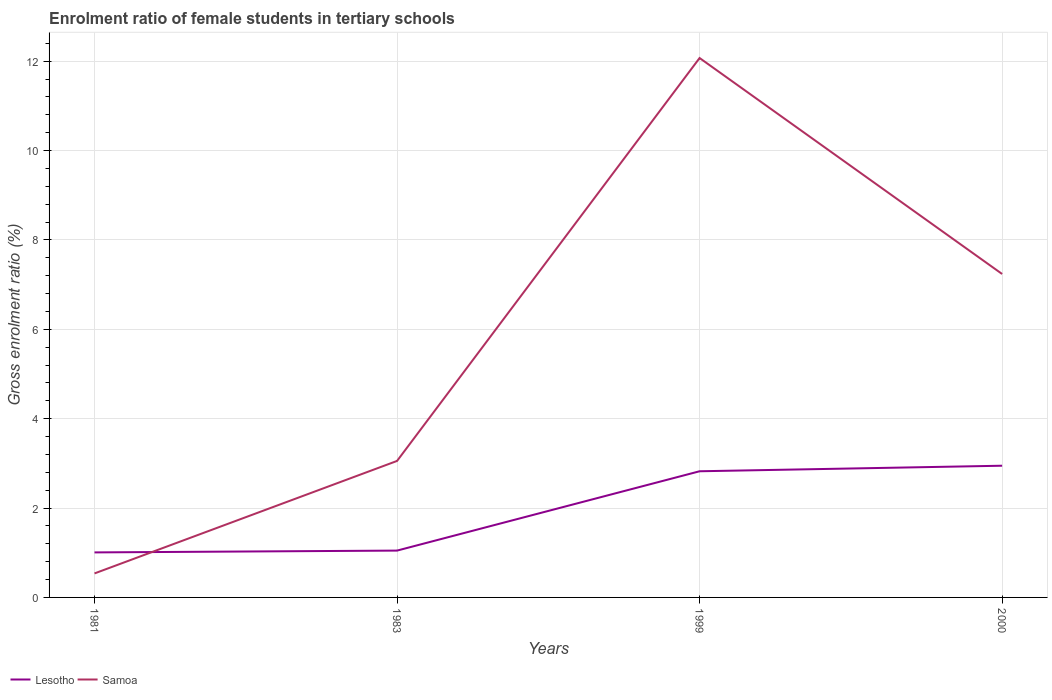How many different coloured lines are there?
Offer a terse response. 2. Across all years, what is the maximum enrolment ratio of female students in tertiary schools in Samoa?
Your response must be concise. 0.54. What is the total enrolment ratio of female students in tertiary schools in Lesotho in the graph?
Your response must be concise. -0.12. What is the difference between the highest and the second highest enrolment ratio of female students in tertiary schools in Samoa?
Make the answer very short. 11.53. What is the difference between the highest and the lowest enrolment ratio of female students in tertiary schools in Samoa?
Make the answer very short. 2. Is the enrolment ratio of female students in tertiary schools in Samoa strictly greater than the enrolment ratio of female students in tertiary schools in Lesotho over the years?
Keep it short and to the point. No. How many years are there in the graph?
Your response must be concise. 4. Does the graph contain any zero values?
Give a very brief answer. No. Where does the legend appear in the graph?
Your response must be concise. Bottom left. How many legend labels are there?
Make the answer very short. 2. What is the title of the graph?
Your response must be concise. Enrolment ratio of female students in tertiary schools. What is the label or title of the X-axis?
Give a very brief answer. Years. What is the label or title of the Y-axis?
Your answer should be very brief. Gross enrolment ratio (%). What is the Gross enrolment ratio (%) in Lesotho in 1981?
Offer a very short reply. 1.01. What is the Gross enrolment ratio (%) in Samoa in 1981?
Your answer should be compact. 0.54. What is the Gross enrolment ratio (%) in Lesotho in 1983?
Provide a succinct answer. 1.05. What is the Gross enrolment ratio (%) in Samoa in 1983?
Offer a terse response. 3.05. What is the Gross enrolment ratio (%) of Lesotho in 1999?
Offer a very short reply. 2.82. What is the Gross enrolment ratio (%) of Samoa in 1999?
Your response must be concise. 12.07. What is the Gross enrolment ratio (%) in Lesotho in 2000?
Your response must be concise. 2.95. What is the Gross enrolment ratio (%) of Samoa in 2000?
Offer a very short reply. 7.24. Across all years, what is the maximum Gross enrolment ratio (%) of Lesotho?
Offer a very short reply. 2.95. Across all years, what is the maximum Gross enrolment ratio (%) of Samoa?
Provide a short and direct response. 12.07. Across all years, what is the minimum Gross enrolment ratio (%) in Lesotho?
Your response must be concise. 1.01. Across all years, what is the minimum Gross enrolment ratio (%) of Samoa?
Keep it short and to the point. 0.54. What is the total Gross enrolment ratio (%) in Lesotho in the graph?
Keep it short and to the point. 7.83. What is the total Gross enrolment ratio (%) in Samoa in the graph?
Provide a succinct answer. 22.9. What is the difference between the Gross enrolment ratio (%) of Lesotho in 1981 and that in 1983?
Give a very brief answer. -0.04. What is the difference between the Gross enrolment ratio (%) in Samoa in 1981 and that in 1983?
Offer a terse response. -2.52. What is the difference between the Gross enrolment ratio (%) of Lesotho in 1981 and that in 1999?
Offer a terse response. -1.82. What is the difference between the Gross enrolment ratio (%) in Samoa in 1981 and that in 1999?
Your answer should be compact. -11.53. What is the difference between the Gross enrolment ratio (%) of Lesotho in 1981 and that in 2000?
Provide a succinct answer. -1.94. What is the difference between the Gross enrolment ratio (%) of Samoa in 1981 and that in 2000?
Ensure brevity in your answer.  -6.7. What is the difference between the Gross enrolment ratio (%) in Lesotho in 1983 and that in 1999?
Keep it short and to the point. -1.78. What is the difference between the Gross enrolment ratio (%) of Samoa in 1983 and that in 1999?
Ensure brevity in your answer.  -9.02. What is the difference between the Gross enrolment ratio (%) of Lesotho in 1983 and that in 2000?
Offer a very short reply. -1.9. What is the difference between the Gross enrolment ratio (%) in Samoa in 1983 and that in 2000?
Offer a terse response. -4.18. What is the difference between the Gross enrolment ratio (%) in Lesotho in 1999 and that in 2000?
Your answer should be compact. -0.12. What is the difference between the Gross enrolment ratio (%) of Samoa in 1999 and that in 2000?
Keep it short and to the point. 4.83. What is the difference between the Gross enrolment ratio (%) of Lesotho in 1981 and the Gross enrolment ratio (%) of Samoa in 1983?
Your response must be concise. -2.05. What is the difference between the Gross enrolment ratio (%) of Lesotho in 1981 and the Gross enrolment ratio (%) of Samoa in 1999?
Your answer should be very brief. -11.06. What is the difference between the Gross enrolment ratio (%) of Lesotho in 1981 and the Gross enrolment ratio (%) of Samoa in 2000?
Make the answer very short. -6.23. What is the difference between the Gross enrolment ratio (%) in Lesotho in 1983 and the Gross enrolment ratio (%) in Samoa in 1999?
Offer a very short reply. -11.02. What is the difference between the Gross enrolment ratio (%) of Lesotho in 1983 and the Gross enrolment ratio (%) of Samoa in 2000?
Provide a succinct answer. -6.19. What is the difference between the Gross enrolment ratio (%) in Lesotho in 1999 and the Gross enrolment ratio (%) in Samoa in 2000?
Give a very brief answer. -4.41. What is the average Gross enrolment ratio (%) of Lesotho per year?
Offer a terse response. 1.96. What is the average Gross enrolment ratio (%) in Samoa per year?
Keep it short and to the point. 5.72. In the year 1981, what is the difference between the Gross enrolment ratio (%) of Lesotho and Gross enrolment ratio (%) of Samoa?
Make the answer very short. 0.47. In the year 1983, what is the difference between the Gross enrolment ratio (%) in Lesotho and Gross enrolment ratio (%) in Samoa?
Offer a very short reply. -2.01. In the year 1999, what is the difference between the Gross enrolment ratio (%) in Lesotho and Gross enrolment ratio (%) in Samoa?
Keep it short and to the point. -9.25. In the year 2000, what is the difference between the Gross enrolment ratio (%) in Lesotho and Gross enrolment ratio (%) in Samoa?
Give a very brief answer. -4.29. What is the ratio of the Gross enrolment ratio (%) in Lesotho in 1981 to that in 1983?
Provide a short and direct response. 0.96. What is the ratio of the Gross enrolment ratio (%) in Samoa in 1981 to that in 1983?
Make the answer very short. 0.18. What is the ratio of the Gross enrolment ratio (%) of Lesotho in 1981 to that in 1999?
Your response must be concise. 0.36. What is the ratio of the Gross enrolment ratio (%) of Samoa in 1981 to that in 1999?
Your response must be concise. 0.04. What is the ratio of the Gross enrolment ratio (%) of Lesotho in 1981 to that in 2000?
Your answer should be very brief. 0.34. What is the ratio of the Gross enrolment ratio (%) of Samoa in 1981 to that in 2000?
Provide a short and direct response. 0.07. What is the ratio of the Gross enrolment ratio (%) of Lesotho in 1983 to that in 1999?
Your response must be concise. 0.37. What is the ratio of the Gross enrolment ratio (%) of Samoa in 1983 to that in 1999?
Your answer should be very brief. 0.25. What is the ratio of the Gross enrolment ratio (%) in Lesotho in 1983 to that in 2000?
Ensure brevity in your answer.  0.36. What is the ratio of the Gross enrolment ratio (%) of Samoa in 1983 to that in 2000?
Provide a short and direct response. 0.42. What is the ratio of the Gross enrolment ratio (%) in Lesotho in 1999 to that in 2000?
Ensure brevity in your answer.  0.96. What is the ratio of the Gross enrolment ratio (%) of Samoa in 1999 to that in 2000?
Provide a short and direct response. 1.67. What is the difference between the highest and the second highest Gross enrolment ratio (%) of Lesotho?
Ensure brevity in your answer.  0.12. What is the difference between the highest and the second highest Gross enrolment ratio (%) in Samoa?
Your answer should be compact. 4.83. What is the difference between the highest and the lowest Gross enrolment ratio (%) in Lesotho?
Offer a terse response. 1.94. What is the difference between the highest and the lowest Gross enrolment ratio (%) of Samoa?
Make the answer very short. 11.53. 